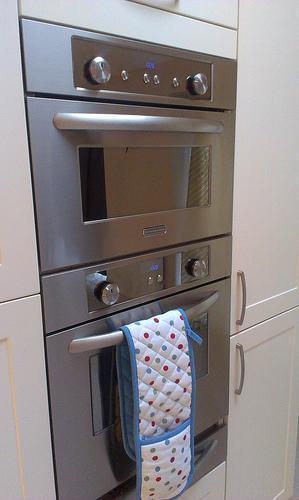How many oven holders are hanging on the bottom oven in the image?
Give a very brief answer. 1. 